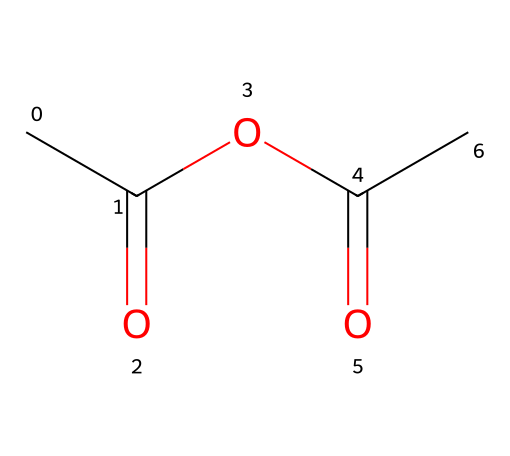What is the molecular formula of this chemical? To determine the molecular formula, identify the number of each type of atom from the SMILES representation. There are two carbon (C) atoms in the two acyl groups and four in total from the acetic part; there are four hydrogen (H) atoms, and the oxygen (O) count is two from the ester link. Thus, the molecular formula is C4H6O3.
Answer: C4H6O3 How many carbon atoms are in this structure? Count the number of carbon (C) atoms represented in the SMILES string. There are four distinct carbon atoms indicated in the structure.
Answer: 4 What type of functional group is present in acetic anhydride? The structure contains two acyl groups linked through an oxygen, which forms the anhydride functional group. An anhydride is characterized by the presence of two acyl residues.
Answer: anhydride How many oxygen atoms are present in this compound? Count the oxygen (O) atoms in the SMILES representation. There are three oxygen atoms, one from each acyl group and one linking them.
Answer: 3 What is the total number of bonds in this structure? Analyze the structure: each carbon typically forms four bonds, counting the single and double bonds present. In this case, we have a total of six bonds formed (three single and three double bonds).
Answer: 6 What type of chemical is acetic anhydride? Acetic anhydride is classified as an acid anhydride, which is a compound derived from an acid by the removal of a water molecule, specifically an acetic acid derivative in this case.
Answer: acid anhydride 